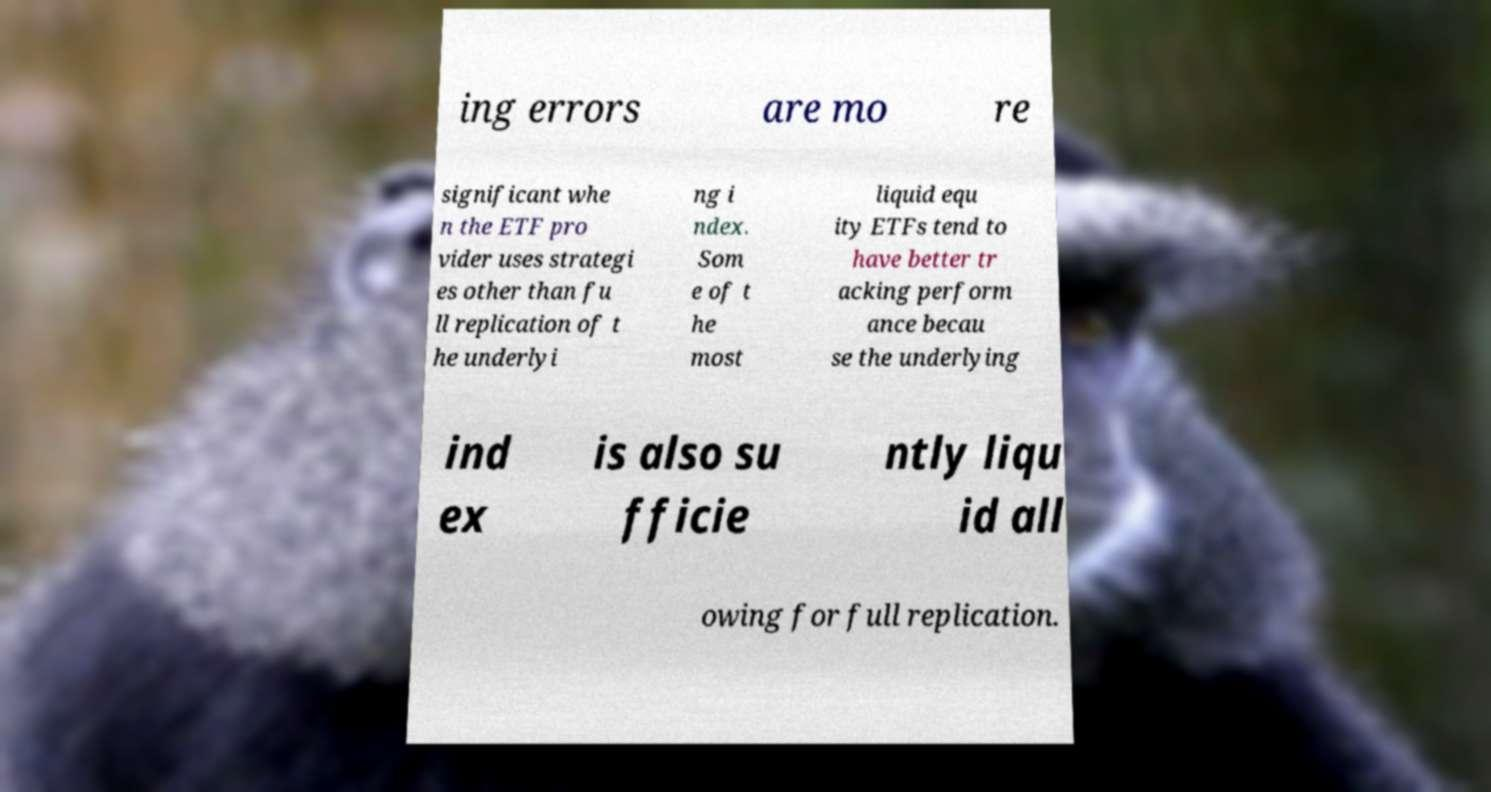What messages or text are displayed in this image? I need them in a readable, typed format. ing errors are mo re significant whe n the ETF pro vider uses strategi es other than fu ll replication of t he underlyi ng i ndex. Som e of t he most liquid equ ity ETFs tend to have better tr acking perform ance becau se the underlying ind ex is also su fficie ntly liqu id all owing for full replication. 